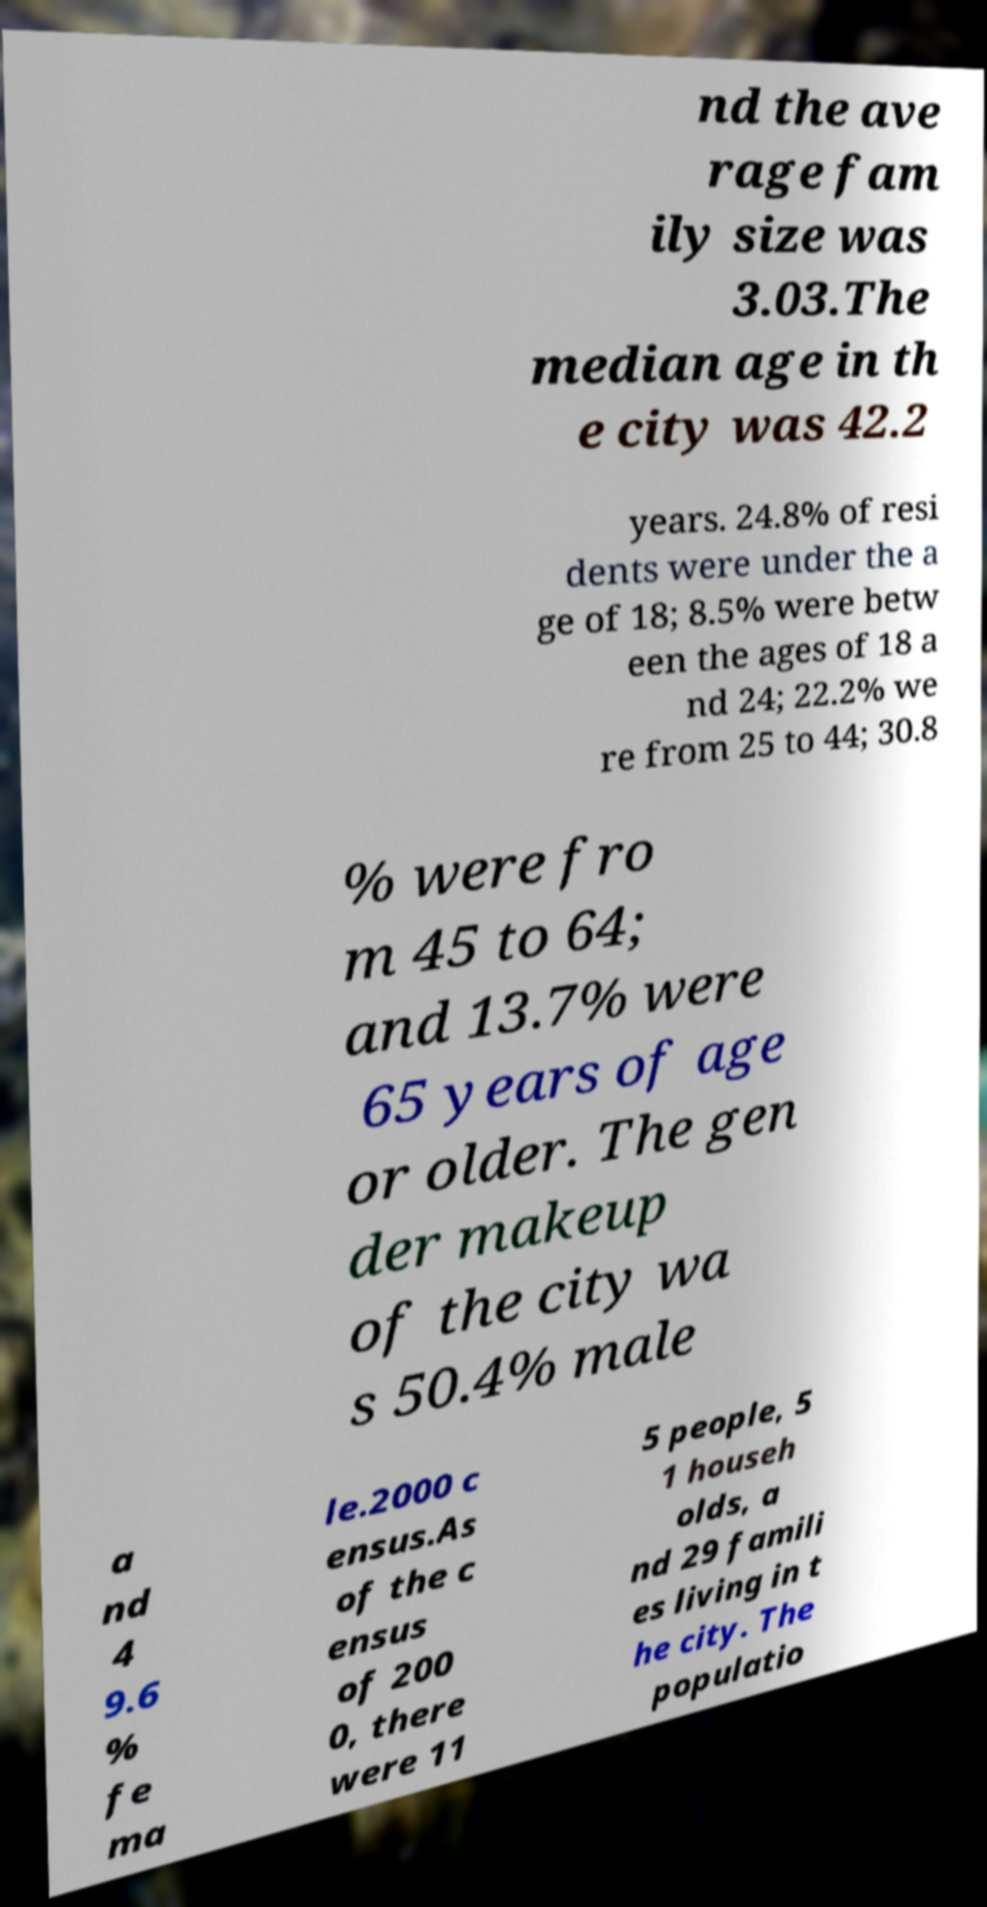There's text embedded in this image that I need extracted. Can you transcribe it verbatim? nd the ave rage fam ily size was 3.03.The median age in th e city was 42.2 years. 24.8% of resi dents were under the a ge of 18; 8.5% were betw een the ages of 18 a nd 24; 22.2% we re from 25 to 44; 30.8 % were fro m 45 to 64; and 13.7% were 65 years of age or older. The gen der makeup of the city wa s 50.4% male a nd 4 9.6 % fe ma le.2000 c ensus.As of the c ensus of 200 0, there were 11 5 people, 5 1 househ olds, a nd 29 famili es living in t he city. The populatio 